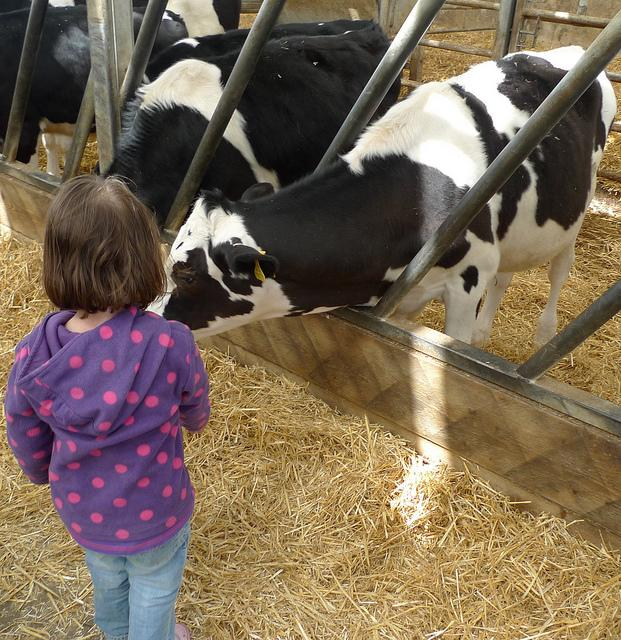What is near the cows?

Choices:
A) cat
B) bodybuilder
C) little girl
D) apple little girl 